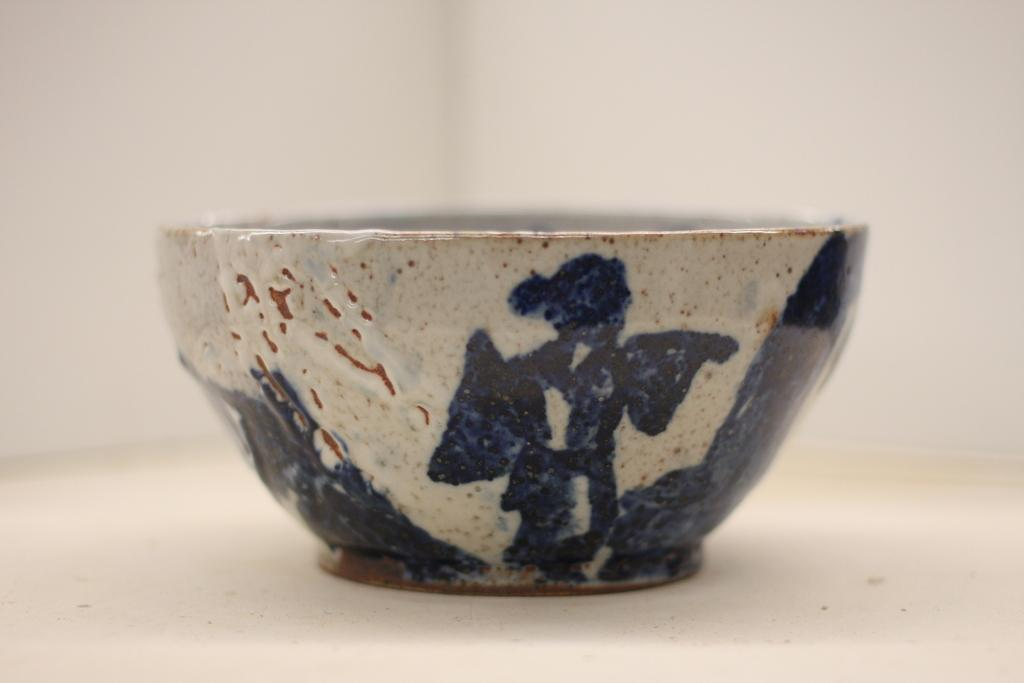What is the main object in the image? There is a bowl or vessel in the image. What material is the bowl or vessel made of? The bowl or vessel is made of stoneware. Are there any decorations or designs on the bowl or vessel? Yes, painting is done on the bowl or vessel. How would you describe the background of the image? The background of the image is white and blurry. What type of pear is being used as a pancake topping in the image? There is no pear or pancake present in the image. How many beads are visible on the bowl or vessel in the image? There are no beads visible on the bowl or vessel in the image. 